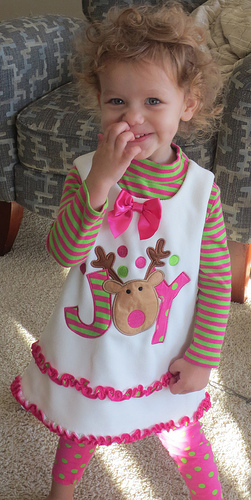<image>
Is there a chair behind the girl? Yes. From this viewpoint, the chair is positioned behind the girl, with the girl partially or fully occluding the chair. 